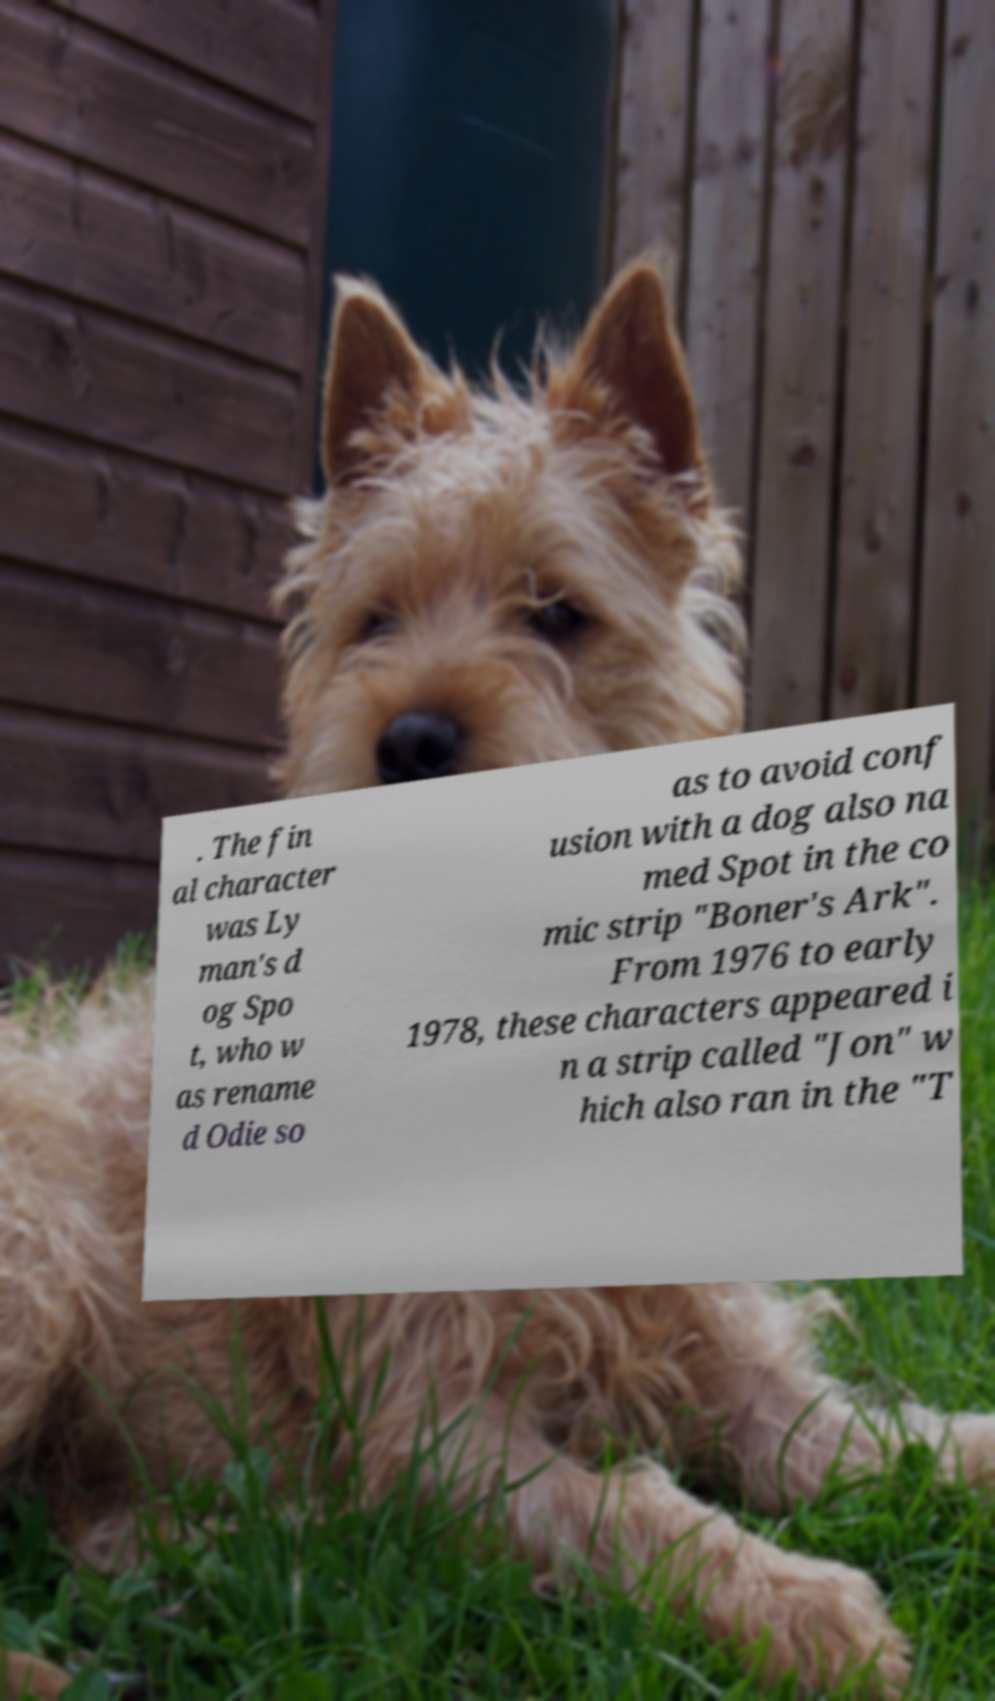Please identify and transcribe the text found in this image. . The fin al character was Ly man's d og Spo t, who w as rename d Odie so as to avoid conf usion with a dog also na med Spot in the co mic strip "Boner's Ark". From 1976 to early 1978, these characters appeared i n a strip called "Jon" w hich also ran in the "T 